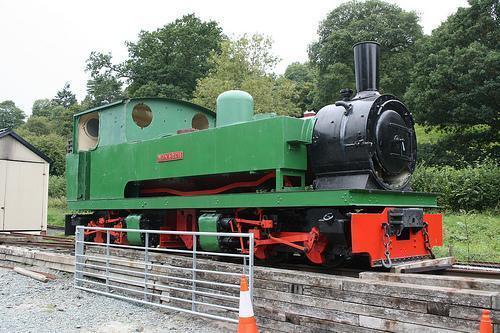How many trains do you see?
Give a very brief answer. 1. 